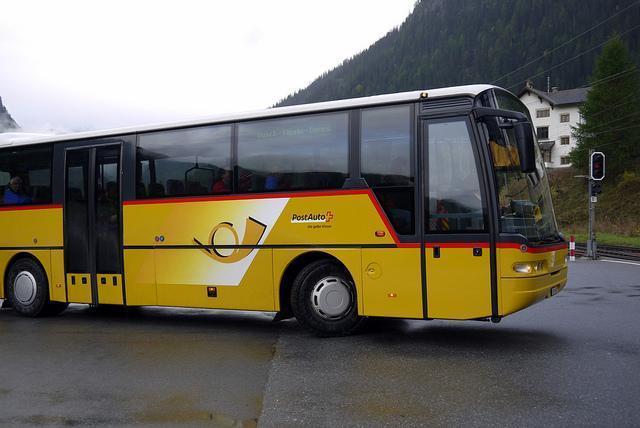How many of the bus's doors can be seen in this photo?
Give a very brief answer. 2. 